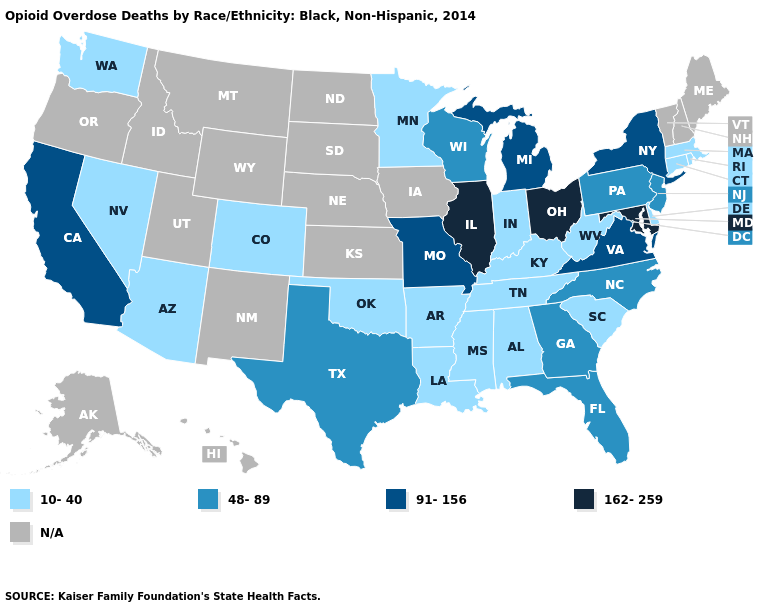Name the states that have a value in the range N/A?
Quick response, please. Alaska, Hawaii, Idaho, Iowa, Kansas, Maine, Montana, Nebraska, New Hampshire, New Mexico, North Dakota, Oregon, South Dakota, Utah, Vermont, Wyoming. Does the map have missing data?
Concise answer only. Yes. Among the states that border Massachusetts , which have the lowest value?
Keep it brief. Connecticut, Rhode Island. Which states hav the highest value in the South?
Quick response, please. Maryland. What is the value of Connecticut?
Concise answer only. 10-40. Is the legend a continuous bar?
Short answer required. No. Name the states that have a value in the range 162-259?
Quick response, please. Illinois, Maryland, Ohio. Does Alabama have the lowest value in the USA?
Keep it brief. Yes. Name the states that have a value in the range N/A?
Short answer required. Alaska, Hawaii, Idaho, Iowa, Kansas, Maine, Montana, Nebraska, New Hampshire, New Mexico, North Dakota, Oregon, South Dakota, Utah, Vermont, Wyoming. Which states have the lowest value in the West?
Be succinct. Arizona, Colorado, Nevada, Washington. What is the lowest value in states that border Alabama?
Keep it brief. 10-40. Name the states that have a value in the range N/A?
Quick response, please. Alaska, Hawaii, Idaho, Iowa, Kansas, Maine, Montana, Nebraska, New Hampshire, New Mexico, North Dakota, Oregon, South Dakota, Utah, Vermont, Wyoming. Does the first symbol in the legend represent the smallest category?
Answer briefly. Yes. 